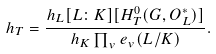<formula> <loc_0><loc_0><loc_500><loc_500>h _ { T } = \frac { h _ { L } [ L \colon K ] [ H ^ { 0 } _ { T } ( G , O _ { L } ^ { * } ) ] } { h _ { K } \prod _ { v } e _ { v } ( L / K ) } .</formula> 